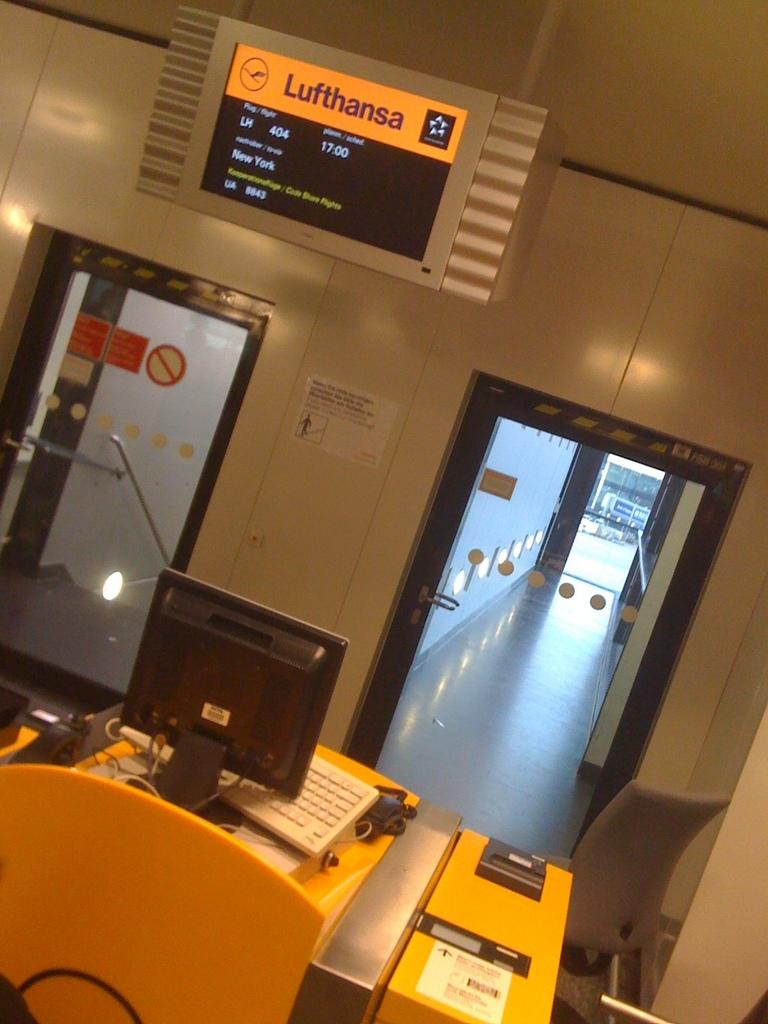Provide a one-sentence caption for the provided image. A sign states flight 404 information for Lufthansa airlines. 